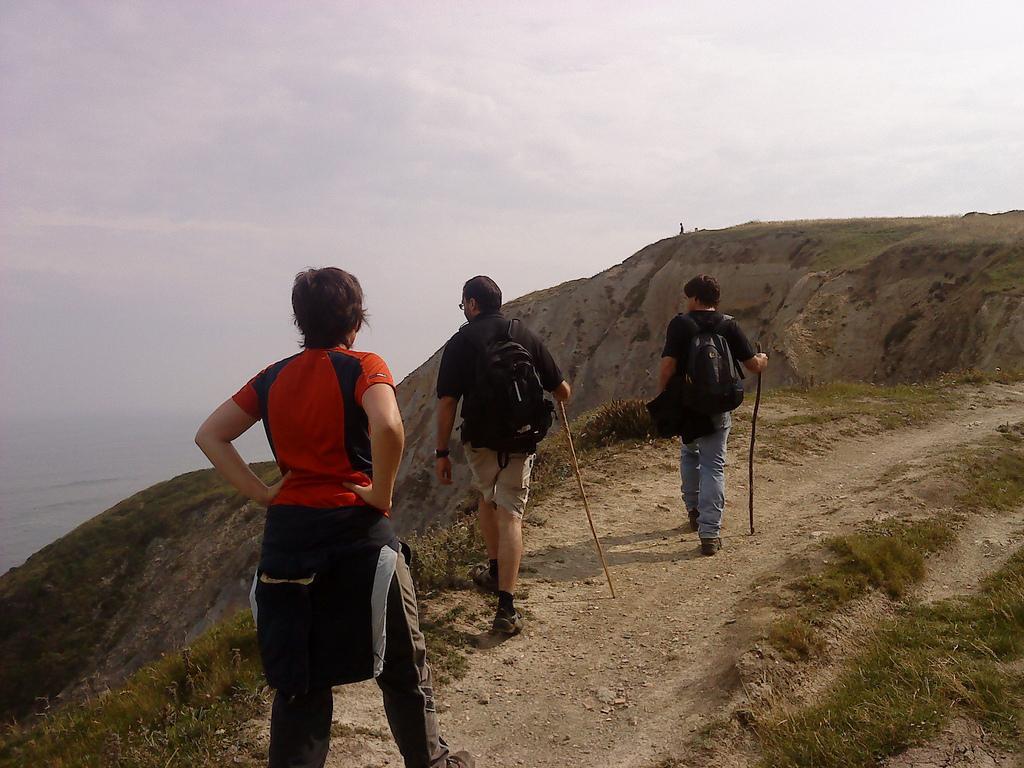In one or two sentences, can you explain what this image depicts? In the picture I can see these people are walking on the hills and these two people are carrying backpacks and holding sticks in their hands. Here we can see hills and cloudy sky in the background. 